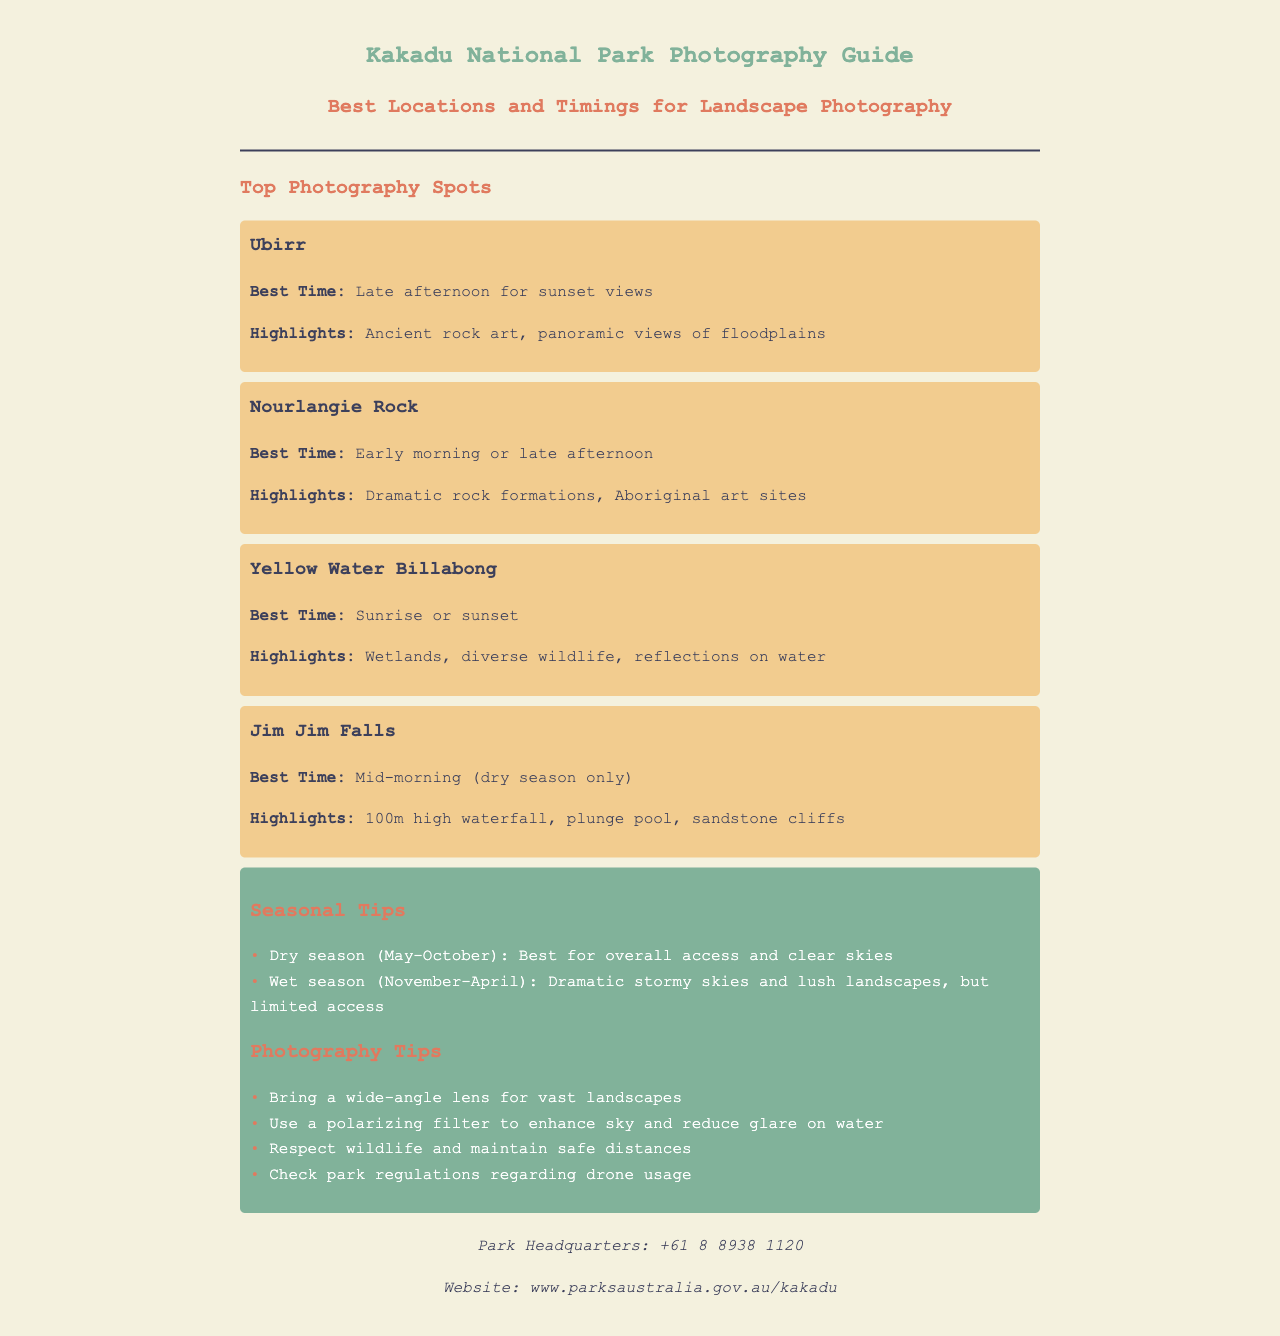What are the best times to photograph Ubirr? The document states the best time to photograph Ubirr is during the late afternoon for sunset views.
Answer: Late afternoon What are the highlights of Nourlangie Rock? The highlights of Nourlangie Rock include dramatic rock formations and Aboriginal art sites as mentioned in the document.
Answer: Dramatic rock formations, Aboriginal art sites When is the dry season in Kakadu National Park? The dry season is defined in the document as running from May to October.
Answer: May-October What photography tips are given for reducing glare on water? The document suggests using a polarizing filter to enhance the sky and reduce glare on water.
Answer: Use a polarizing filter What is the contact number for the park headquarters? The document provides the contact number for the park headquarters as +61 8 8938 1120.
Answer: +61 8 8938 1120 Which location is best for capturing sunrise or sunset? The document indicates that both Yellow Water Billabong is best captured at sunrise or sunset.
Answer: Yellow Water Billabong What should photographers respect in the park? According to the document, photographers should respect wildlife and maintain safe distances.
Answer: Wildlife When is the best time to capture Jim Jim Falls? The best time to capture Jim Jim Falls is mid-morning during the dry season only, as stated in the document.
Answer: Mid-morning (dry season only) 